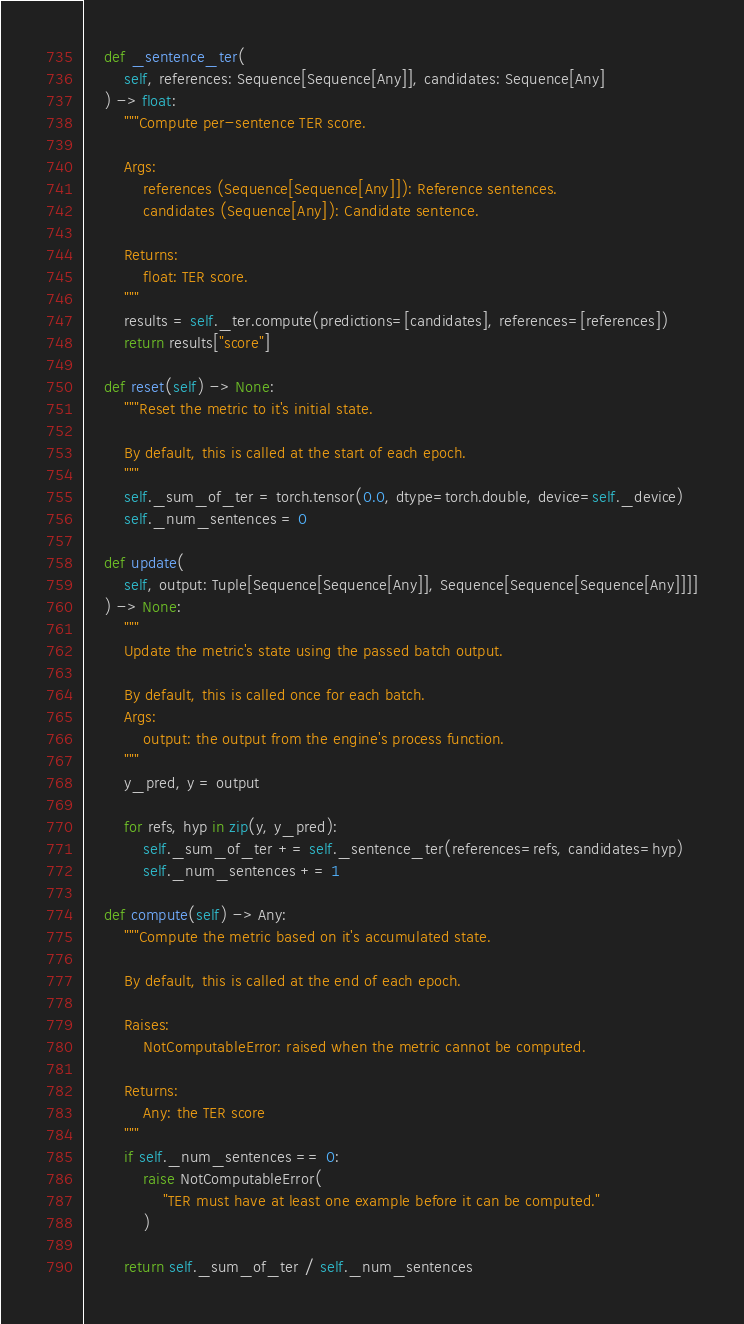<code> <loc_0><loc_0><loc_500><loc_500><_Python_>
    def _sentence_ter(
        self, references: Sequence[Sequence[Any]], candidates: Sequence[Any]
    ) -> float:
        """Compute per-sentence TER score.

        Args:
            references (Sequence[Sequence[Any]]): Reference sentences.
            candidates (Sequence[Any]): Candidate sentence.

        Returns:
            float: TER score.
        """
        results = self._ter.compute(predictions=[candidates], references=[references])
        return results["score"]

    def reset(self) -> None:
        """Reset the metric to it's initial state.

        By default, this is called at the start of each epoch.
        """
        self._sum_of_ter = torch.tensor(0.0, dtype=torch.double, device=self._device)
        self._num_sentences = 0

    def update(
        self, output: Tuple[Sequence[Sequence[Any]], Sequence[Sequence[Sequence[Any]]]]
    ) -> None:
        """
        Update the metric's state using the passed batch output.

        By default, this is called once for each batch.
        Args:
            output: the output from the engine's process function.
        """
        y_pred, y = output

        for refs, hyp in zip(y, y_pred):
            self._sum_of_ter += self._sentence_ter(references=refs, candidates=hyp)
            self._num_sentences += 1

    def compute(self) -> Any:
        """Compute the metric based on it's accumulated state.

        By default, this is called at the end of each epoch.

        Raises:
            NotComputableError: raised when the metric cannot be computed.

        Returns:
            Any: the TER score
        """
        if self._num_sentences == 0:
            raise NotComputableError(
                "TER must have at least one example before it can be computed."
            )

        return self._sum_of_ter / self._num_sentences
</code> 